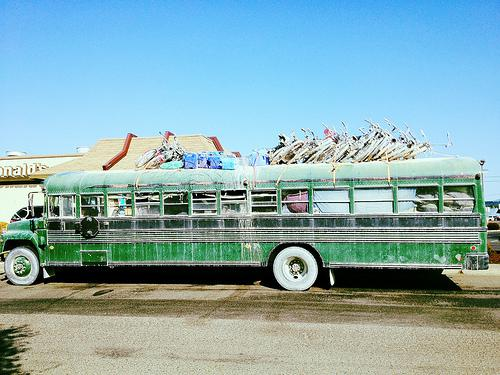Question: what color is the bus?
Choices:
A. Yellow.
B. Blue.
C. Green.
D. White.
Answer with the letter. Answer: C Question: where is the bus located?
Choices:
A. At the bus station.
B. Near the station.
C. Behind the car.
D. In a service area.
Answer with the letter. Answer: D Question: why did they stop?
Choices:
A. They were tired.
B. They were cold.
C. The place was closing.
D. To take a break and eat.
Answer with the letter. Answer: D 